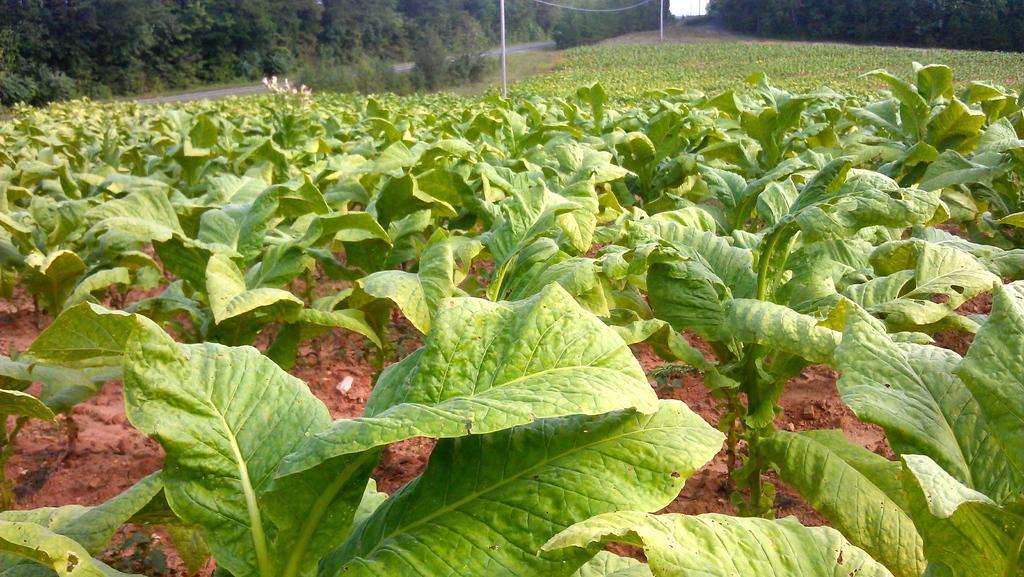Please provide a concise description of this image. In this image I can see plants and flowers. And there is a pole with that, Pole there is a thin wire attached to that. And at back side there are trees, Road and a sky. 